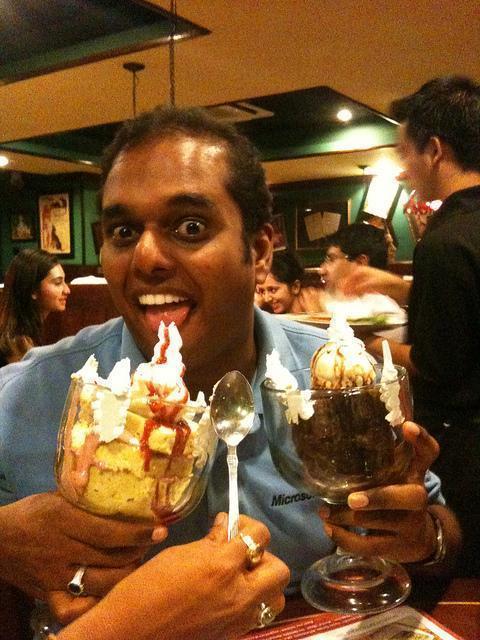What company might the man in the blue shirt work for?
Pick the correct solution from the four options below to address the question.
Options: Apple, microsoft, samsung, sony. Microsoft. 